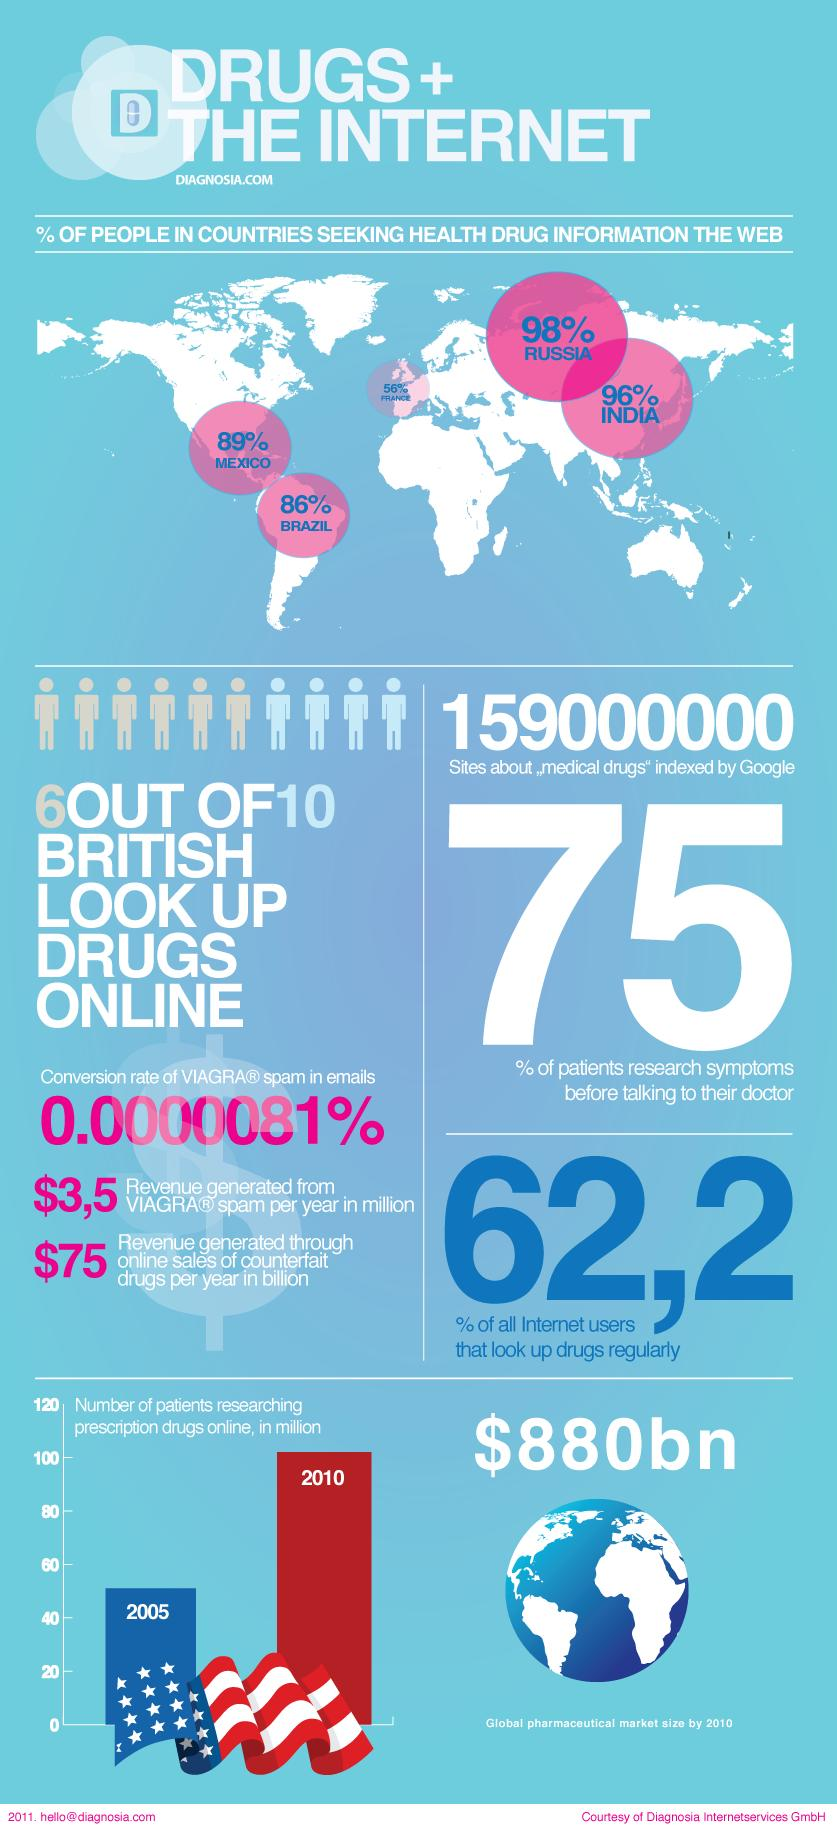Identify some key points in this picture. According to a recent survey, 96% of people in India are seeking health drug information on the web. According to a survey, 25% of people do not research symptoms before speaking with their doctor. According to recent data, a significant majority of people in Mexico, approximately 89%, are seeking health and drug information on the web. 